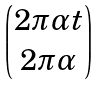<formula> <loc_0><loc_0><loc_500><loc_500>\begin{pmatrix} 2 \pi \alpha t \\ 2 \pi \alpha \end{pmatrix}</formula> 